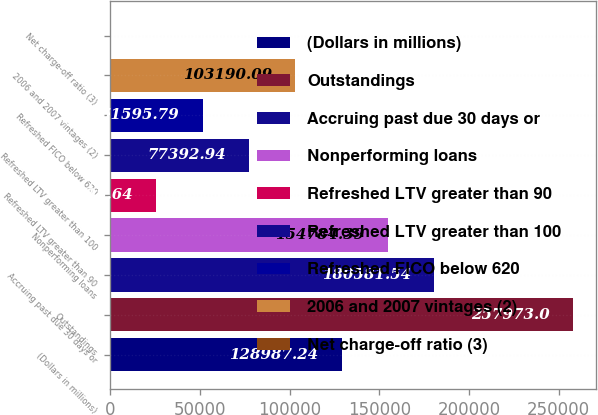Convert chart. <chart><loc_0><loc_0><loc_500><loc_500><bar_chart><fcel>(Dollars in millions)<fcel>Outstandings<fcel>Accruing past due 30 days or<fcel>Nonperforming loans<fcel>Refreshed LTV greater than 90<fcel>Refreshed LTV greater than 100<fcel>Refreshed FICO below 620<fcel>2006 and 2007 vintages (2)<fcel>Net charge-off ratio (3)<nl><fcel>128987<fcel>257973<fcel>180582<fcel>154784<fcel>25798.6<fcel>77392.9<fcel>51595.8<fcel>103190<fcel>1.49<nl></chart> 